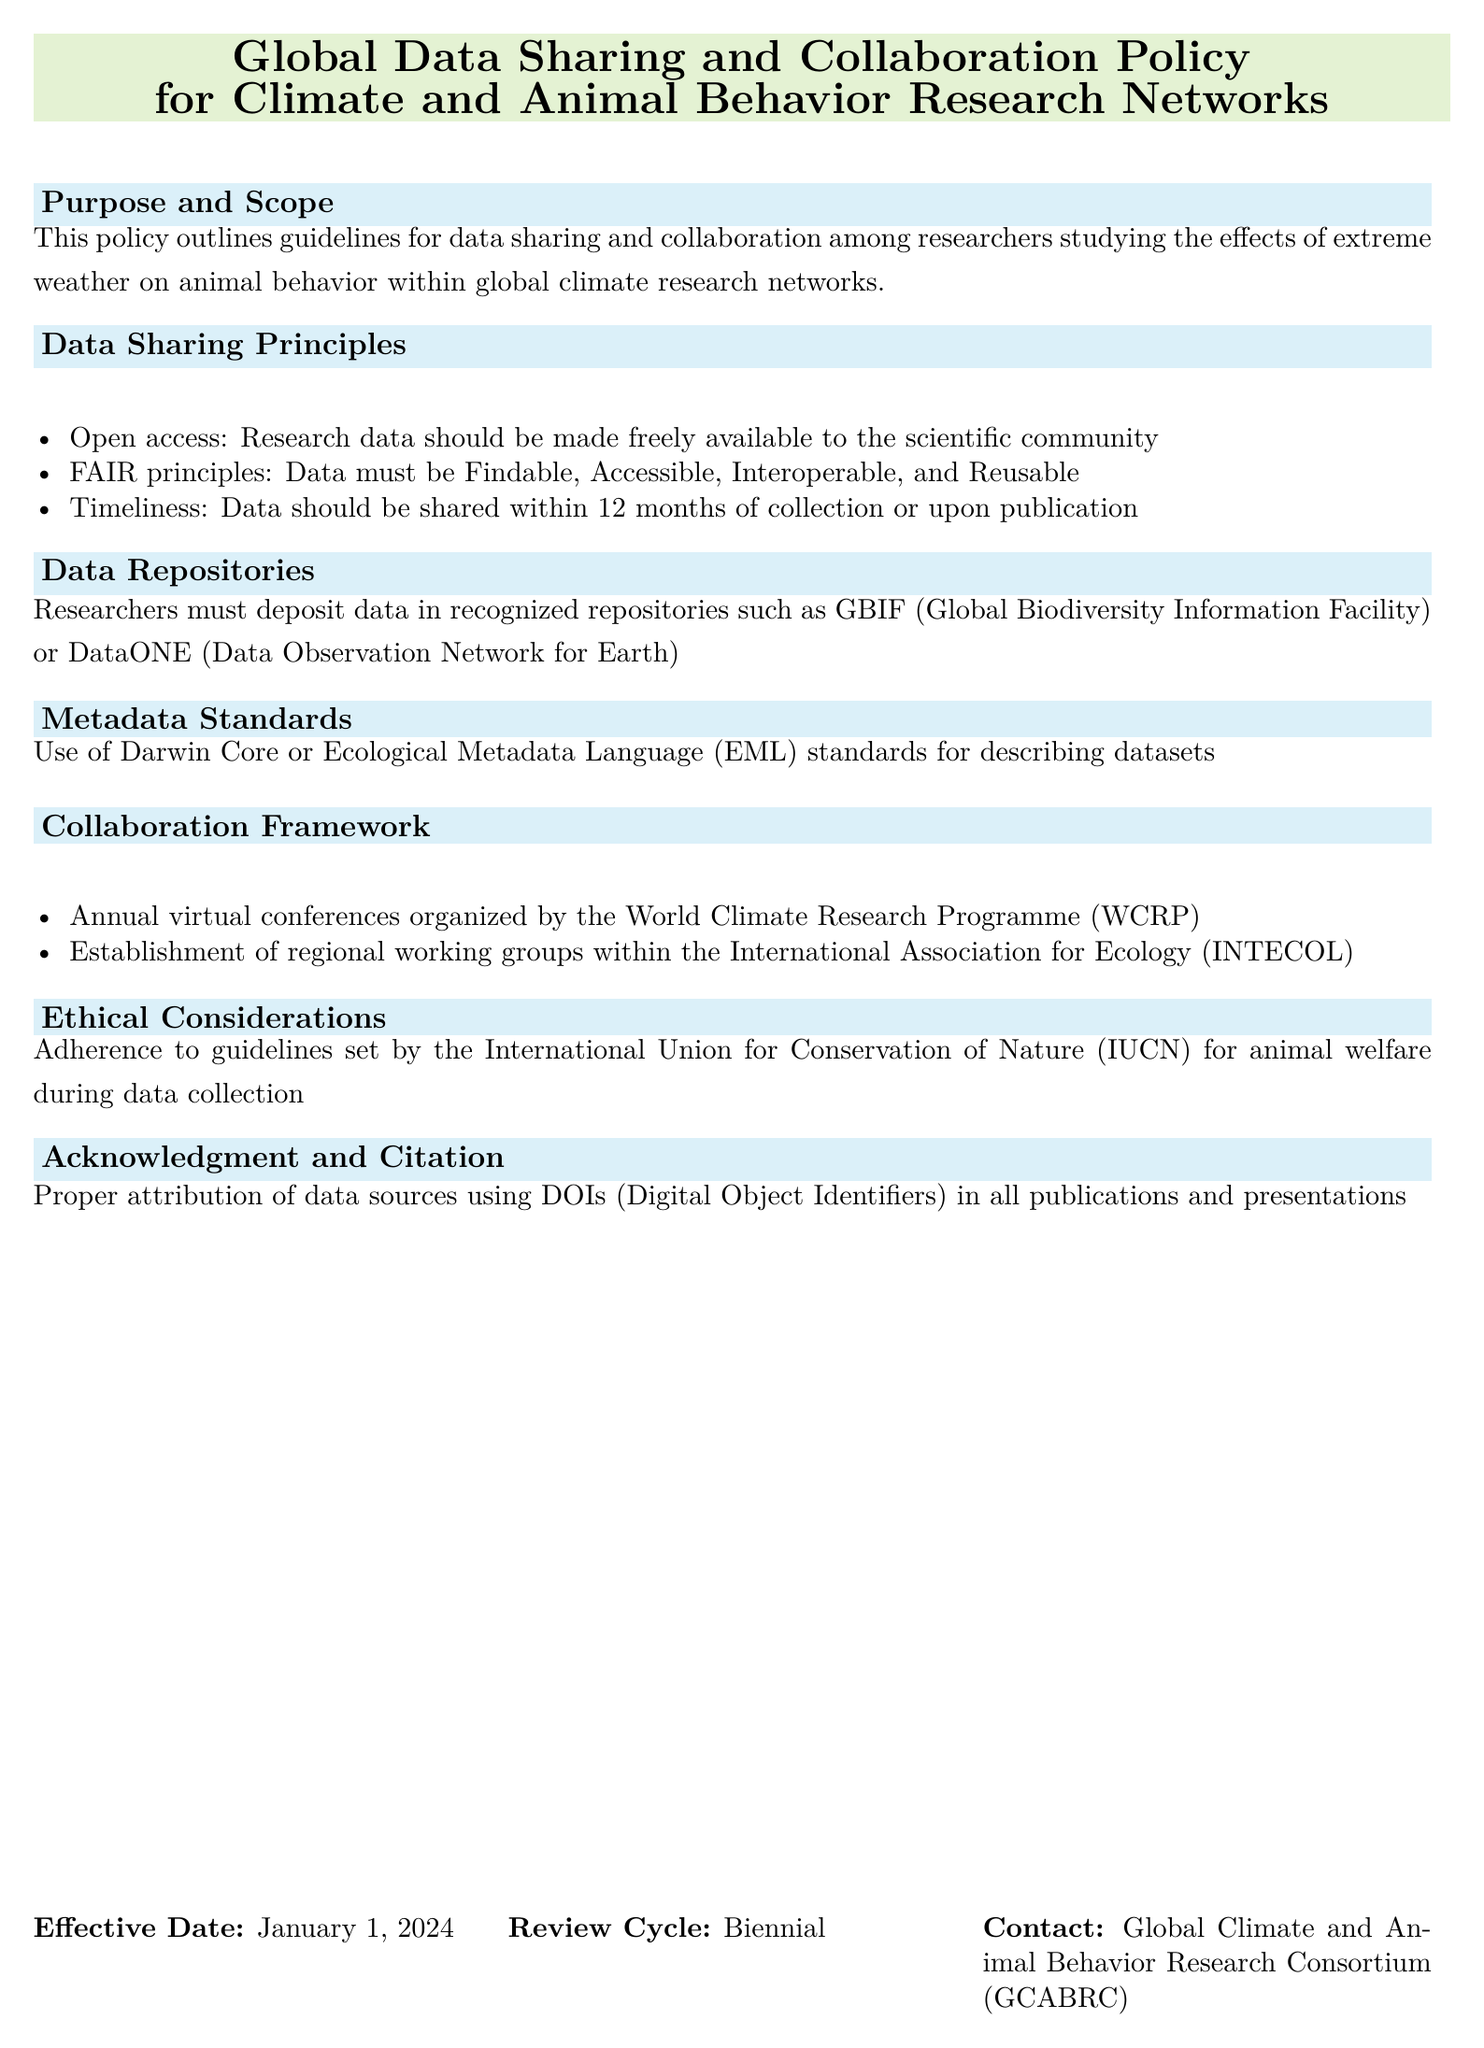What is the purpose of the policy? The policy outlines guidelines for data sharing and collaboration among researchers studying the effects of extreme weather on animal behavior within global climate research networks.
Answer: Guidelines for data sharing and collaboration What is the timeline for data sharing after collection? The policy states that data should be shared within 12 months of collection or upon publication.
Answer: 12 months Which metadata standards should be used? The document specifies the use of Darwin Core or Ecological Metadata Language (EML) standards for describing datasets.
Answer: Darwin Core or EML Who organizes the annual virtual conferences? The annual virtual conferences are organized by the World Climate Research Programme (WCRP).
Answer: World Climate Research Programme (WCRP) What ethical guidelines must be adhered to? Researchers must adhere to guidelines set by the International Union for Conservation of Nature (IUCN) for animal welfare during data collection.
Answer: IUCN What is the effective date of the policy? The effective date is explicitly mentioned in the document as January 1, 2024.
Answer: January 1, 2024 How often will the policy be reviewed? The document states that the review cycle of the policy is biennial.
Answer: Biennial In which repositories should researchers deposit data? The recognized repositories for data deposition mentioned in the document include GBIF and DataONE.
Answer: GBIF or DataONE 